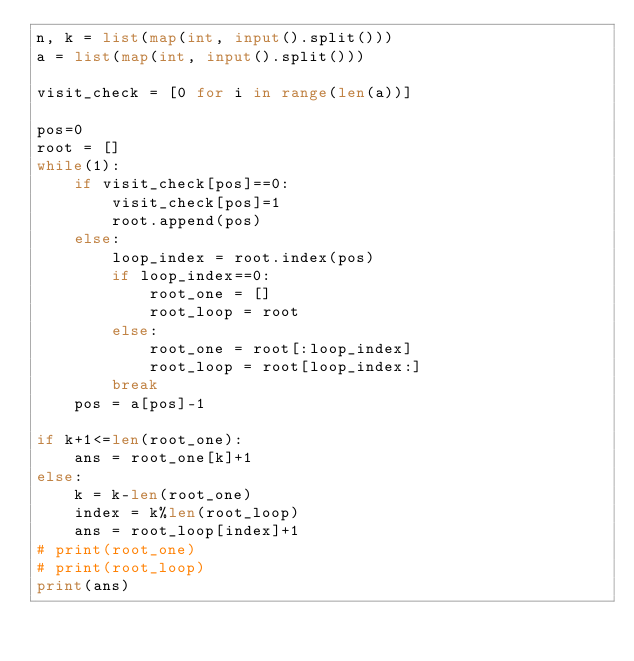<code> <loc_0><loc_0><loc_500><loc_500><_Python_>n, k = list(map(int, input().split()))
a = list(map(int, input().split()))

visit_check = [0 for i in range(len(a))]

pos=0
root = []
while(1):
    if visit_check[pos]==0:
        visit_check[pos]=1
        root.append(pos)
    else:
        loop_index = root.index(pos)
        if loop_index==0:
            root_one = []
            root_loop = root
        else:
            root_one = root[:loop_index]
            root_loop = root[loop_index:]
        break
    pos = a[pos]-1

if k+1<=len(root_one):
    ans = root_one[k]+1
else:
    k = k-len(root_one)
    index = k%len(root_loop)
    ans = root_loop[index]+1
# print(root_one)
# print(root_loop)
print(ans)
</code> 